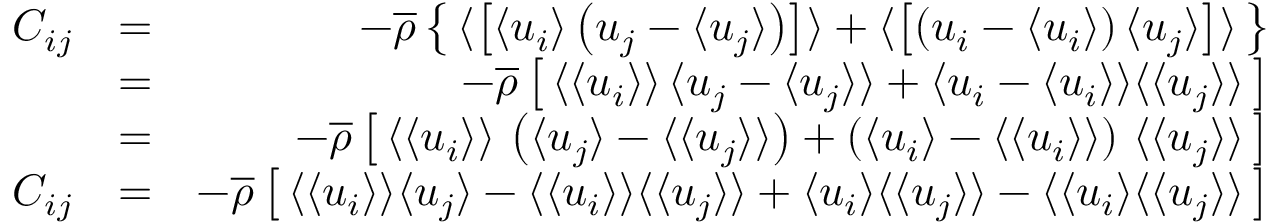<formula> <loc_0><loc_0><loc_500><loc_500>\begin{array} { r l r } { C _ { i j } } & { = } & { - \overline { \rho } \left \{ \, \langle \left [ { \langle u _ { i } \rangle \left ( u _ { j } - \langle u _ { j } \rangle \right ) } \right ] \rangle + \langle \left [ { \left ( u _ { i } - \langle u _ { i } \rangle \right ) \langle u _ { j } \rangle } \right ] \rangle \, \right \} } \\ & { = } & { - \overline { \rho } \left [ \, \langle \langle u _ { i } \rangle \rangle \, \langle u _ { j } - \langle u _ { j } \rangle \rangle + \langle u _ { i } - \langle u _ { i } \rangle \rangle \langle \langle u _ { j } \rangle \rangle \, \right ] } \\ & { = } & { - \overline { \rho } \left [ \, \langle \langle u _ { i } \rangle \rangle \, \left ( \langle u _ { j } \rangle - \langle \langle u _ { j } \rangle \rangle \right ) + \left ( \langle u _ { i } \rangle - \langle \langle u _ { i } \rangle \rangle \right ) \, \langle \langle u _ { j } \rangle \rangle \, \right ] } \\ { C _ { i j } } & { = } & { - \overline { \rho } \left [ \, \langle \langle u _ { i } \rangle \rangle \langle u _ { j } \rangle - \langle \langle u _ { i } \rangle \rangle \langle \langle u _ { j } \rangle \rangle + \langle u _ { i } \rangle \langle \langle u _ { j } \rangle \rangle - \langle \langle u _ { i } \rangle \langle \langle u _ { j } \rangle \rangle \, \right ] } \end{array}</formula> 